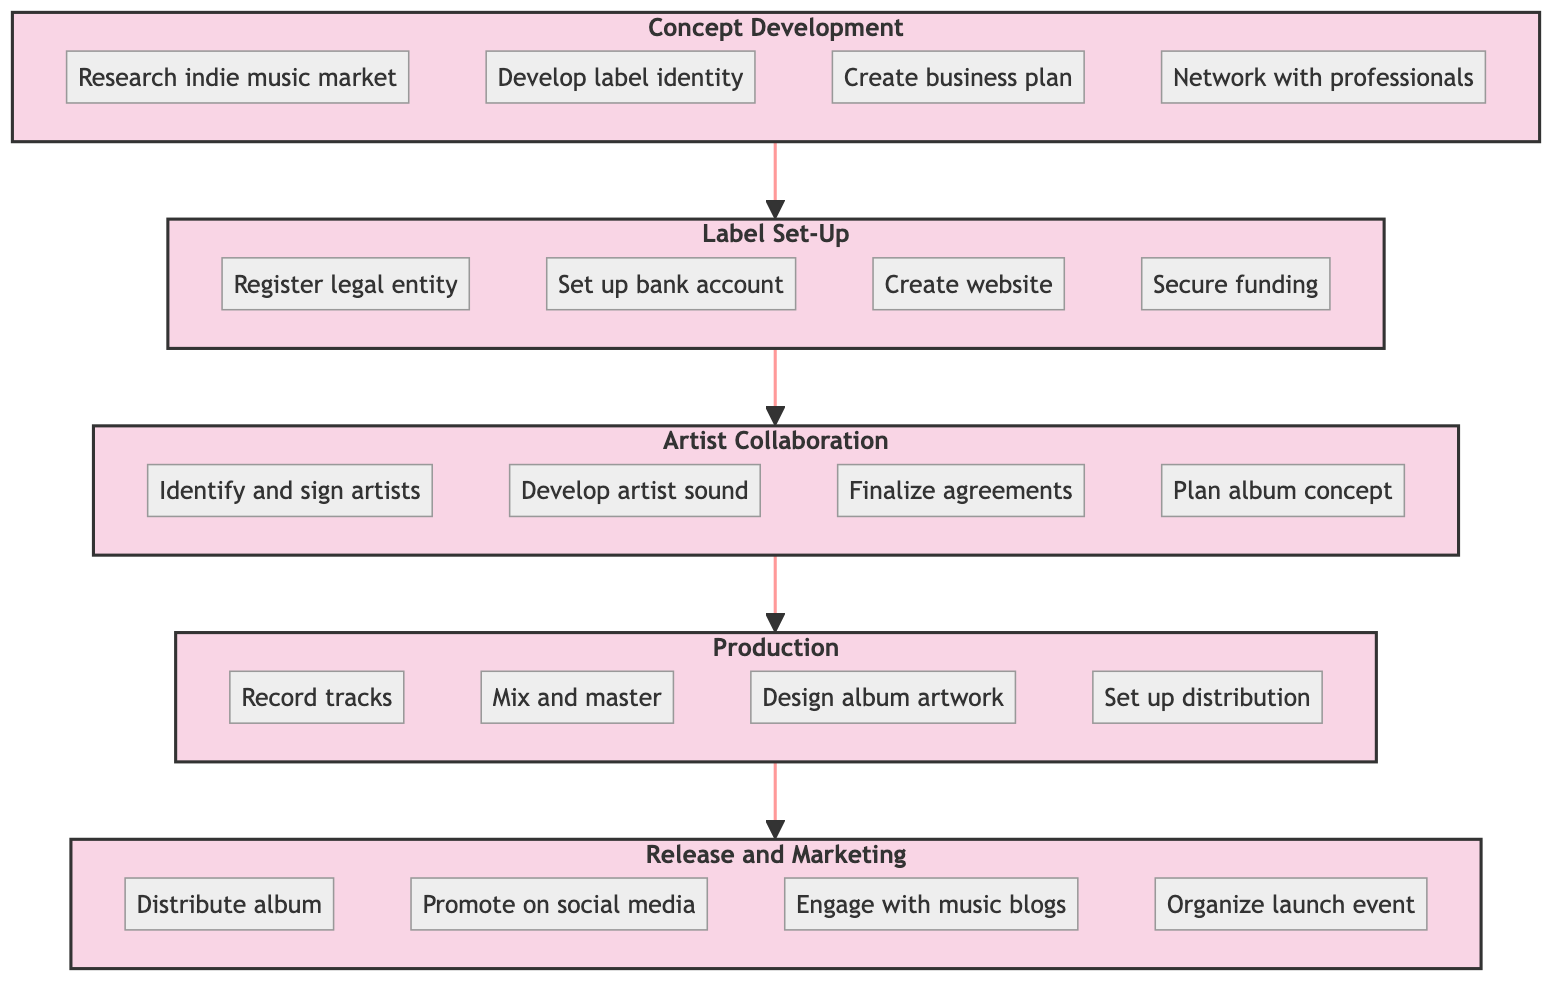What is the first stage in the flowchart? The flowchart outlines the process of starting an indie record label, and the first stage listed at the bottom is "Concept Development."
Answer: Concept Development How many stages are there in total? The diagram contains five distinct stages, including "Concept Development," "Label Set-Up," "Artist Collaboration," "Production," and "Release and Marketing."
Answer: Five What task is associated with the "Production" stage? Within the "Production" stage, several tasks are listed. One task is "Mix and master tracks to ensure high-quality sound."
Answer: Mix and master tracks to ensure high-quality sound Which stage comes after "Label Set-Up"? In the flowchart, the connection shows that "Artist Collaboration" directly follows "Label Set-Up," indicating the flow of processes.
Answer: Artist Collaboration What task is the last action listed in the flowchart? The final stage listed in the flowchart is "Release and Marketing," and the last associated task is "Organize a launch event or virtual listening party."
Answer: Organize a launch event or virtual listening party What action is necessary before starting the "Production" stage? According to the flowchart, "Finalize agreements" is a required action before moving on to the "Production" stage, as it is a task in the preceding "Artist Collaboration" stage.
Answer: Finalize agreements How does "Concept Development" contribute to the process? "Concept Development" is crucial as it establishes the label's identity and vision, creating a foundation for subsequent stages like "Label Set-Up."
Answer: Establishes the label's identity and vision Which task requires collaboration with external professionals? The task "Collaborate with graphic designers for album artwork" in the "Production" stage necessitates working with external professionals, showcasing the collaborative aspect of label production.
Answer: Collaborate with graphic designers for album artwork How many tasks are listed under "Release and Marketing"? There are four tasks listed under "Release and Marketing," emphasizing different aspects of promoting and distributing the album.
Answer: Four 